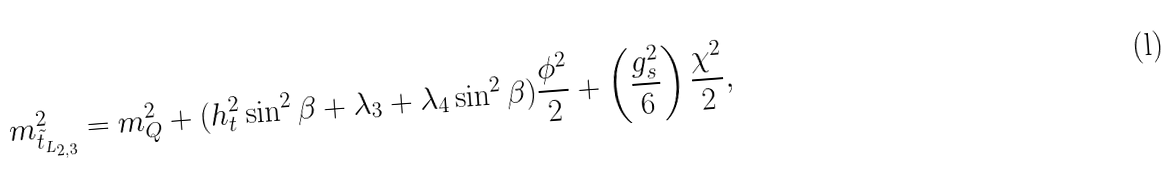<formula> <loc_0><loc_0><loc_500><loc_500>m _ { \tilde { t } _ { L _ { 2 , 3 } } } ^ { 2 } = m _ { Q } ^ { 2 } + ( h _ { t } ^ { 2 } \sin ^ { 2 } \beta + \lambda _ { 3 } + \lambda _ { 4 } \sin ^ { 2 } \beta ) { \frac { \phi ^ { 2 } } { 2 } } + \left ( { \frac { g _ { s } ^ { 2 } } { 6 } } \right ) { \frac { \chi ^ { 2 } } { 2 } } ,</formula> 